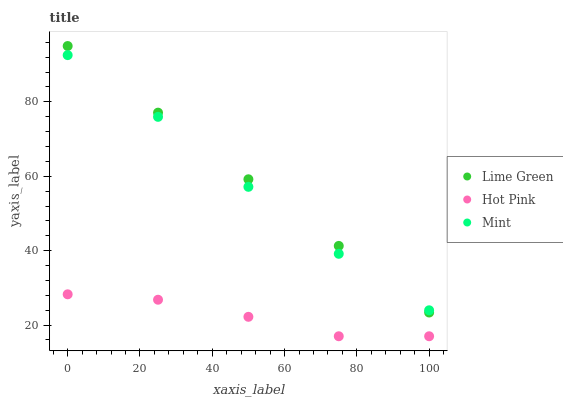Does Hot Pink have the minimum area under the curve?
Answer yes or no. Yes. Does Lime Green have the maximum area under the curve?
Answer yes or no. Yes. Does Lime Green have the minimum area under the curve?
Answer yes or no. No. Does Hot Pink have the maximum area under the curve?
Answer yes or no. No. Is Lime Green the smoothest?
Answer yes or no. Yes. Is Hot Pink the roughest?
Answer yes or no. Yes. Is Hot Pink the smoothest?
Answer yes or no. No. Is Lime Green the roughest?
Answer yes or no. No. Does Hot Pink have the lowest value?
Answer yes or no. Yes. Does Lime Green have the lowest value?
Answer yes or no. No. Does Lime Green have the highest value?
Answer yes or no. Yes. Does Hot Pink have the highest value?
Answer yes or no. No. Is Hot Pink less than Lime Green?
Answer yes or no. Yes. Is Lime Green greater than Hot Pink?
Answer yes or no. Yes. Does Mint intersect Lime Green?
Answer yes or no. Yes. Is Mint less than Lime Green?
Answer yes or no. No. Is Mint greater than Lime Green?
Answer yes or no. No. Does Hot Pink intersect Lime Green?
Answer yes or no. No. 